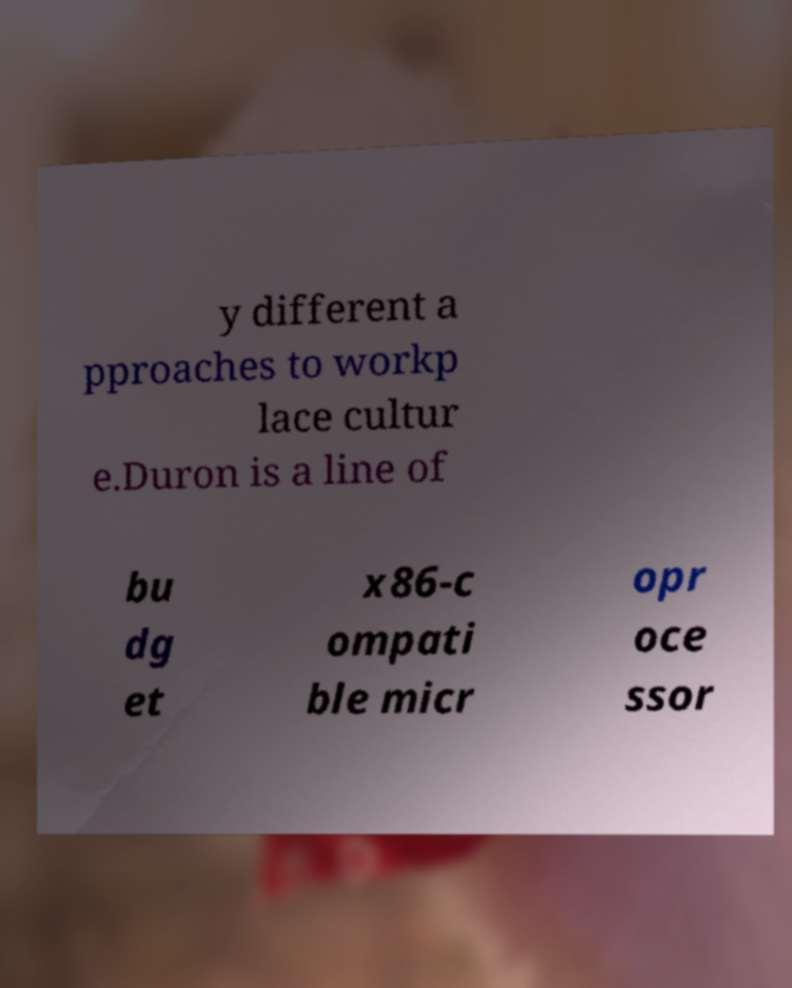Please read and relay the text visible in this image. What does it say? y different a pproaches to workp lace cultur e.Duron is a line of bu dg et x86-c ompati ble micr opr oce ssor 